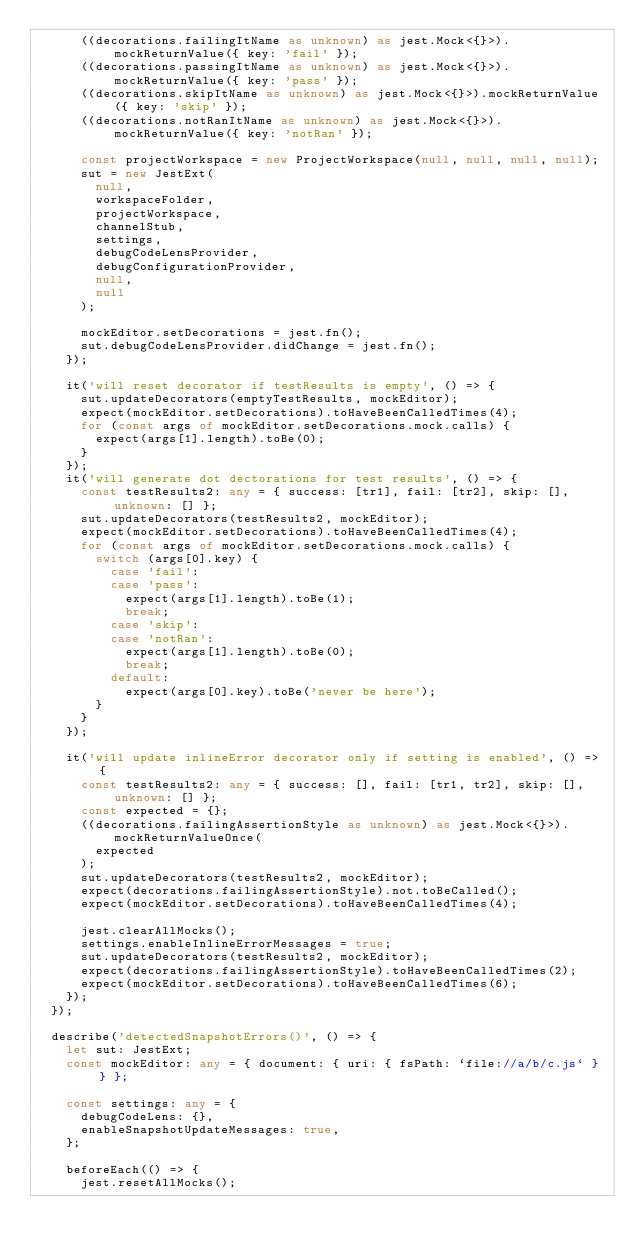<code> <loc_0><loc_0><loc_500><loc_500><_TypeScript_>      ((decorations.failingItName as unknown) as jest.Mock<{}>).mockReturnValue({ key: 'fail' });
      ((decorations.passingItName as unknown) as jest.Mock<{}>).mockReturnValue({ key: 'pass' });
      ((decorations.skipItName as unknown) as jest.Mock<{}>).mockReturnValue({ key: 'skip' });
      ((decorations.notRanItName as unknown) as jest.Mock<{}>).mockReturnValue({ key: 'notRan' });

      const projectWorkspace = new ProjectWorkspace(null, null, null, null);
      sut = new JestExt(
        null,
        workspaceFolder,
        projectWorkspace,
        channelStub,
        settings,
        debugCodeLensProvider,
        debugConfigurationProvider,
        null,
        null
      );

      mockEditor.setDecorations = jest.fn();
      sut.debugCodeLensProvider.didChange = jest.fn();
    });

    it('will reset decorator if testResults is empty', () => {
      sut.updateDecorators(emptyTestResults, mockEditor);
      expect(mockEditor.setDecorations).toHaveBeenCalledTimes(4);
      for (const args of mockEditor.setDecorations.mock.calls) {
        expect(args[1].length).toBe(0);
      }
    });
    it('will generate dot dectorations for test results', () => {
      const testResults2: any = { success: [tr1], fail: [tr2], skip: [], unknown: [] };
      sut.updateDecorators(testResults2, mockEditor);
      expect(mockEditor.setDecorations).toHaveBeenCalledTimes(4);
      for (const args of mockEditor.setDecorations.mock.calls) {
        switch (args[0].key) {
          case 'fail':
          case 'pass':
            expect(args[1].length).toBe(1);
            break;
          case 'skip':
          case 'notRan':
            expect(args[1].length).toBe(0);
            break;
          default:
            expect(args[0].key).toBe('never be here');
        }
      }
    });

    it('will update inlineError decorator only if setting is enabled', () => {
      const testResults2: any = { success: [], fail: [tr1, tr2], skip: [], unknown: [] };
      const expected = {};
      ((decorations.failingAssertionStyle as unknown) as jest.Mock<{}>).mockReturnValueOnce(
        expected
      );
      sut.updateDecorators(testResults2, mockEditor);
      expect(decorations.failingAssertionStyle).not.toBeCalled();
      expect(mockEditor.setDecorations).toHaveBeenCalledTimes(4);

      jest.clearAllMocks();
      settings.enableInlineErrorMessages = true;
      sut.updateDecorators(testResults2, mockEditor);
      expect(decorations.failingAssertionStyle).toHaveBeenCalledTimes(2);
      expect(mockEditor.setDecorations).toHaveBeenCalledTimes(6);
    });
  });

  describe('detectedSnapshotErrors()', () => {
    let sut: JestExt;
    const mockEditor: any = { document: { uri: { fsPath: `file://a/b/c.js` } } };

    const settings: any = {
      debugCodeLens: {},
      enableSnapshotUpdateMessages: true,
    };

    beforeEach(() => {
      jest.resetAllMocks();</code> 